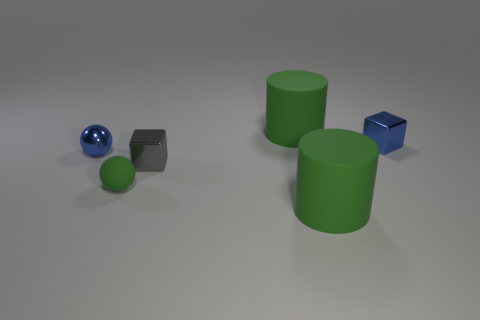Add 1 blue metal blocks. How many objects exist? 7 Subtract all cylinders. How many objects are left? 4 Add 6 green things. How many green things are left? 9 Add 3 big gray metallic things. How many big gray metallic things exist? 3 Subtract 0 red cylinders. How many objects are left? 6 Subtract all small gray shiny cubes. Subtract all brown rubber things. How many objects are left? 5 